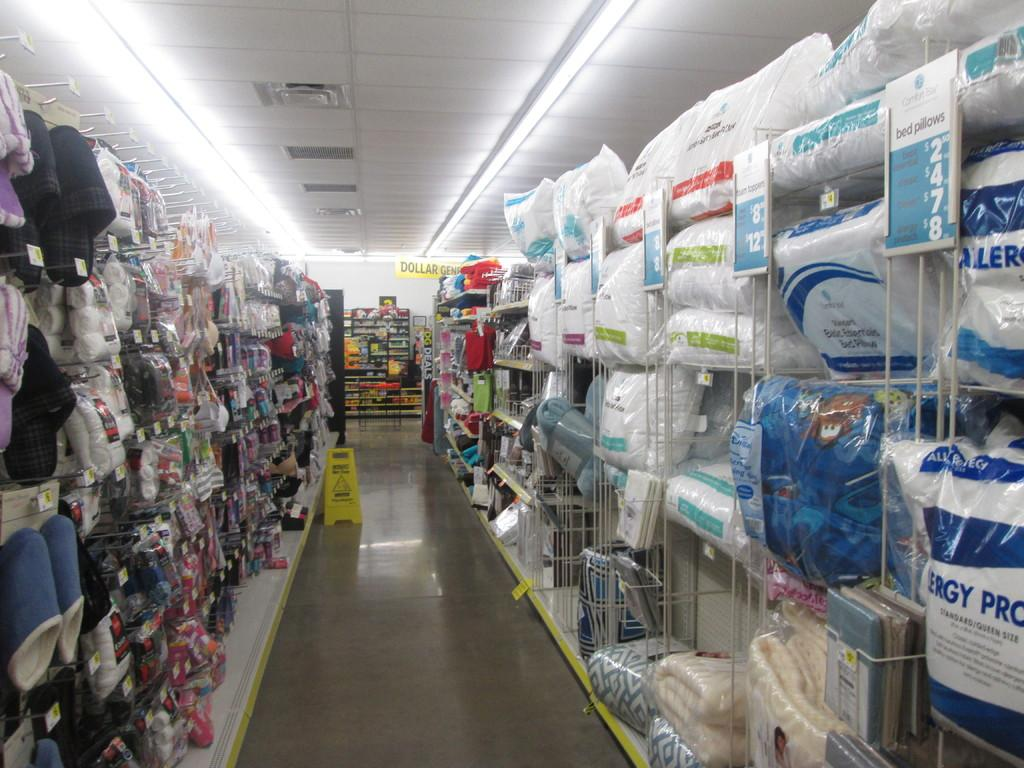<image>
Create a compact narrative representing the image presented. Empty store aisle with a sign that says Wet Floor. 